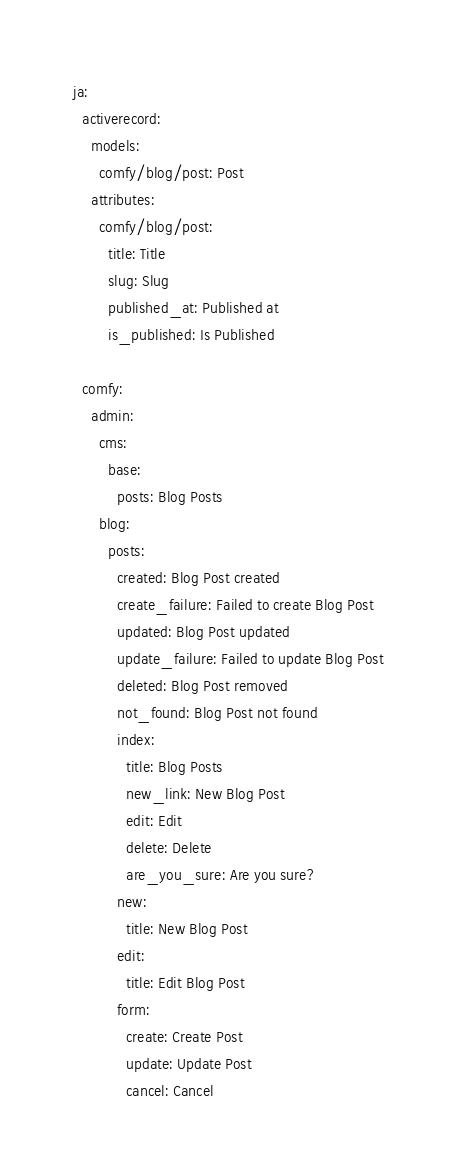<code> <loc_0><loc_0><loc_500><loc_500><_YAML_>ja:
  activerecord:
    models:
      comfy/blog/post: Post
    attributes:
      comfy/blog/post:
        title: Title
        slug: Slug
        published_at: Published at
        is_published: Is Published

  comfy:
    admin:
      cms:
        base:
          posts: Blog Posts
      blog:
        posts:
          created: Blog Post created
          create_failure: Failed to create Blog Post
          updated: Blog Post updated
          update_failure: Failed to update Blog Post
          deleted: Blog Post removed
          not_found: Blog Post not found
          index:
            title: Blog Posts
            new_link: New Blog Post
            edit: Edit
            delete: Delete
            are_you_sure: Are you sure?
          new:
            title: New Blog Post
          edit:
            title: Edit Blog Post
          form:
            create: Create Post
            update: Update Post
            cancel: Cancel
</code> 